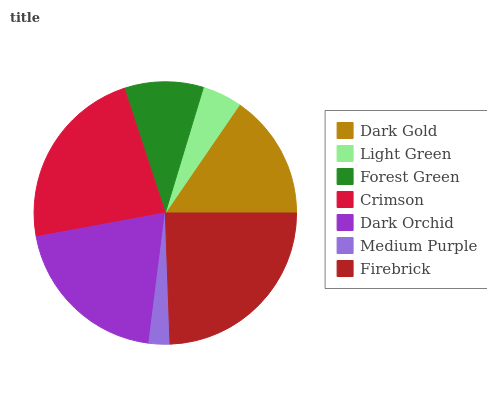Is Medium Purple the minimum?
Answer yes or no. Yes. Is Firebrick the maximum?
Answer yes or no. Yes. Is Light Green the minimum?
Answer yes or no. No. Is Light Green the maximum?
Answer yes or no. No. Is Dark Gold greater than Light Green?
Answer yes or no. Yes. Is Light Green less than Dark Gold?
Answer yes or no. Yes. Is Light Green greater than Dark Gold?
Answer yes or no. No. Is Dark Gold less than Light Green?
Answer yes or no. No. Is Dark Gold the high median?
Answer yes or no. Yes. Is Dark Gold the low median?
Answer yes or no. Yes. Is Dark Orchid the high median?
Answer yes or no. No. Is Forest Green the low median?
Answer yes or no. No. 